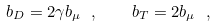Convert formula to latex. <formula><loc_0><loc_0><loc_500><loc_500>b _ { D } = 2 \gamma b _ { \mu } \ , \quad b _ { T } = 2 b _ { \mu } \ ,</formula> 